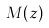<formula> <loc_0><loc_0><loc_500><loc_500>M ( z )</formula> 